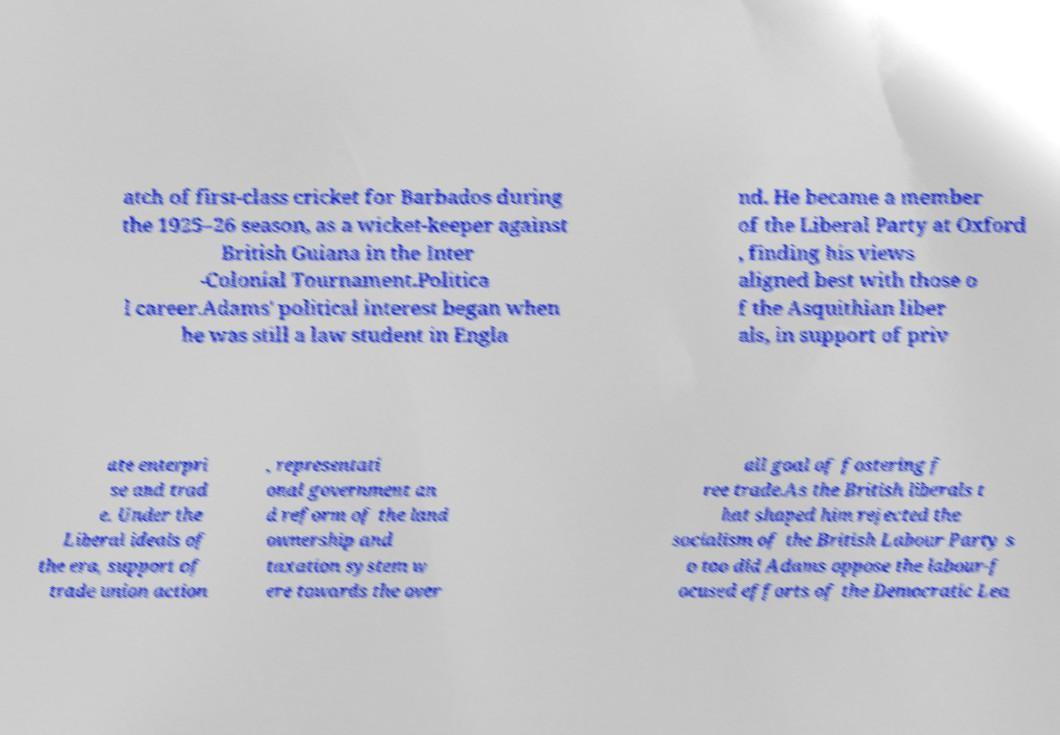Can you accurately transcribe the text from the provided image for me? atch of first-class cricket for Barbados during the 1925–26 season, as a wicket-keeper against British Guiana in the Inter -Colonial Tournament.Politica l career.Adams' political interest began when he was still a law student in Engla nd. He became a member of the Liberal Party at Oxford , finding his views aligned best with those o f the Asquithian liber als, in support of priv ate enterpri se and trad e. Under the Liberal ideals of the era, support of trade union action , representati onal government an d reform of the land ownership and taxation system w ere towards the over all goal of fostering f ree trade.As the British liberals t hat shaped him rejected the socialism of the British Labour Party s o too did Adams oppose the labour-f ocused efforts of the Democratic Lea 